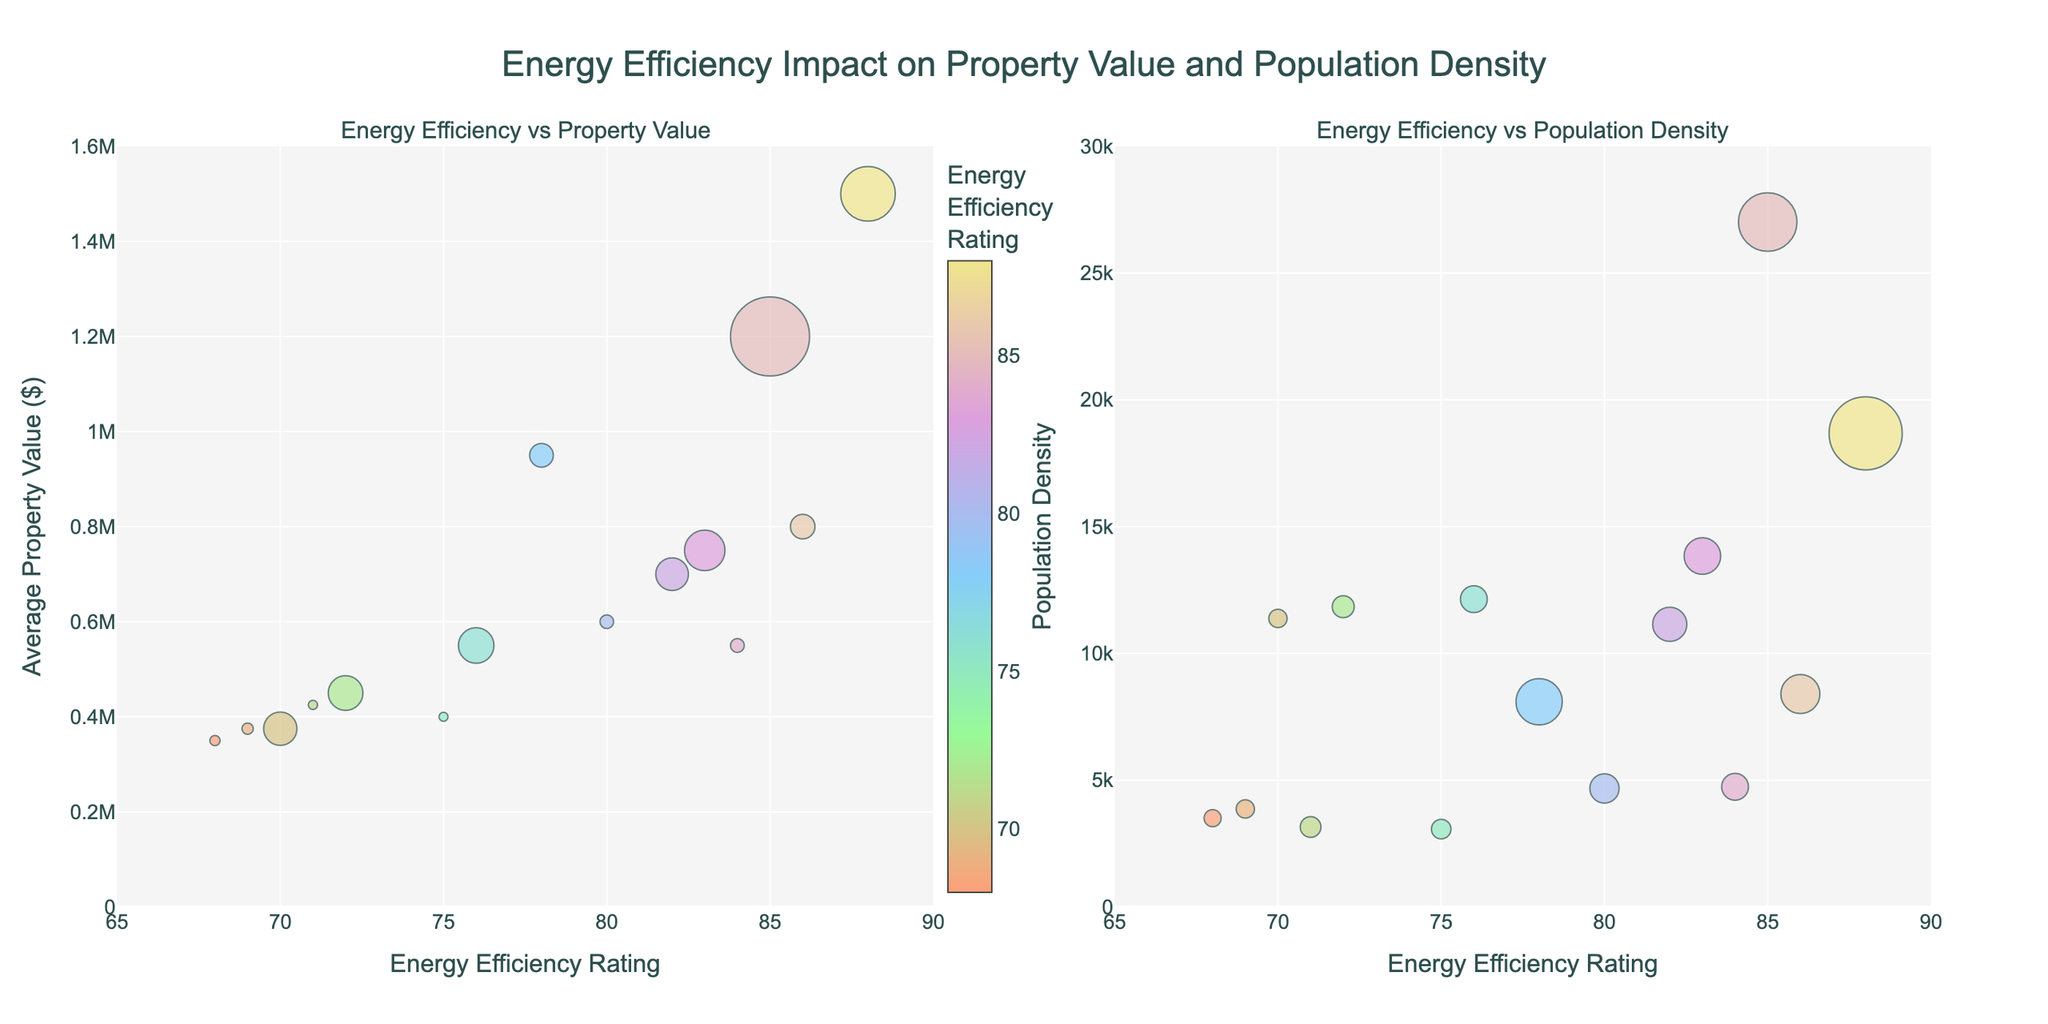What is the title of the figure? The title of the figure is typically located at the top center of the figure. In this case, it states "Time Allocation for IP Law Student's Typical Week".
Answer: Time Allocation for IP Law Student's Typical Week Which activity category has the highest number of hours spent? Looking at the individual pie charts, notably, the 'Personal' category contains the activity 'Personal Time and Rest' with 73 hours. This is the highest number of hours spent among all the activities.
Answer: Personal Time and Rest How many hours are devoted to 'Studying and Research'? In the 'Study' pie chart, the label 'Studying and Research' shows the number of hours allocated to this activity. It is 30 hours.
Answer: 30 What is the total amount of time spent on work-related activities? The 'Work' pie chart includes 'Internship at IP Law Firm' with 10 hours and 'Moot Court Practice' with 5 hours. Summing these gives 10 + 5 = 15 hours.
Answer: 15 How does the time spent on 'Personal Time and Rest' compare to 'Studying and Research'? 'Personal Time and Rest' is 73 hours as seen in the 'Personal' chart, while 'Studying and Research' is 30 hours in the 'Study' chart. Comparing these two, 73 is greater than 30, indicating more time is spent on 'Personal Time and Rest'.
Answer: Personal Time and Rest > Studying and Research What is the proportion of time spent on 'Networking Events' relative to the total hours? Locate the hours for 'Networking Events' in the 'Other' pie chart, which is 3 hours. The total hours spent in the week is 168. The proportion is calculated as (3 / 168) * 100 ≈ 1.79%.
Answer: 1.79% In which category does 'Reading IP Law Journals' belong, and how many hours are allocated to it? 'Reading IP Law Journals' appears in the 'Other' pie chart with 6 hours allocated to this activity.
Answer: Other, 6 Which activity in the 'Study' category takes up the least amount of time? In the 'Study' pie chart, 'Legal Writing and Case Briefs' with 15 hours is the least compared to 'Lectures and Seminars' and 'Studying and Research'.
Answer: Legal Writing and Case Briefs How many hours are spent on 'Legal Tech Workshop'? The 'Other' pie chart includes the 'Legal Tech Workshop' activity, which has 2 hours allocated to it.
Answer: 2 Compare the time spent on 'Patent Law Study Group' and 'Moot Court Practice'. Which one is higher and by how many hours? The 'Other' pie chart shows 'Patent Law Study Group' has 4 hours, whereas the 'Work' pie chart shows 'Moot Court Practice' with 5 hours. 5 - 4 = 1, so 'Moot Court Practice' has 1 hour more than 'Patent Law Study Group'.
Answer: Moot Court Practice, 1 hour more 